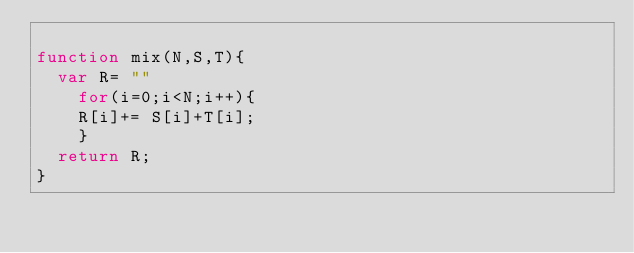<code> <loc_0><loc_0><loc_500><loc_500><_JavaScript_>
function mix(N,S,T){
	var R= ""
    for(i=0;i<N;i++){
    R[i]+= S[i]+T[i];
    }
  return R;
}</code> 